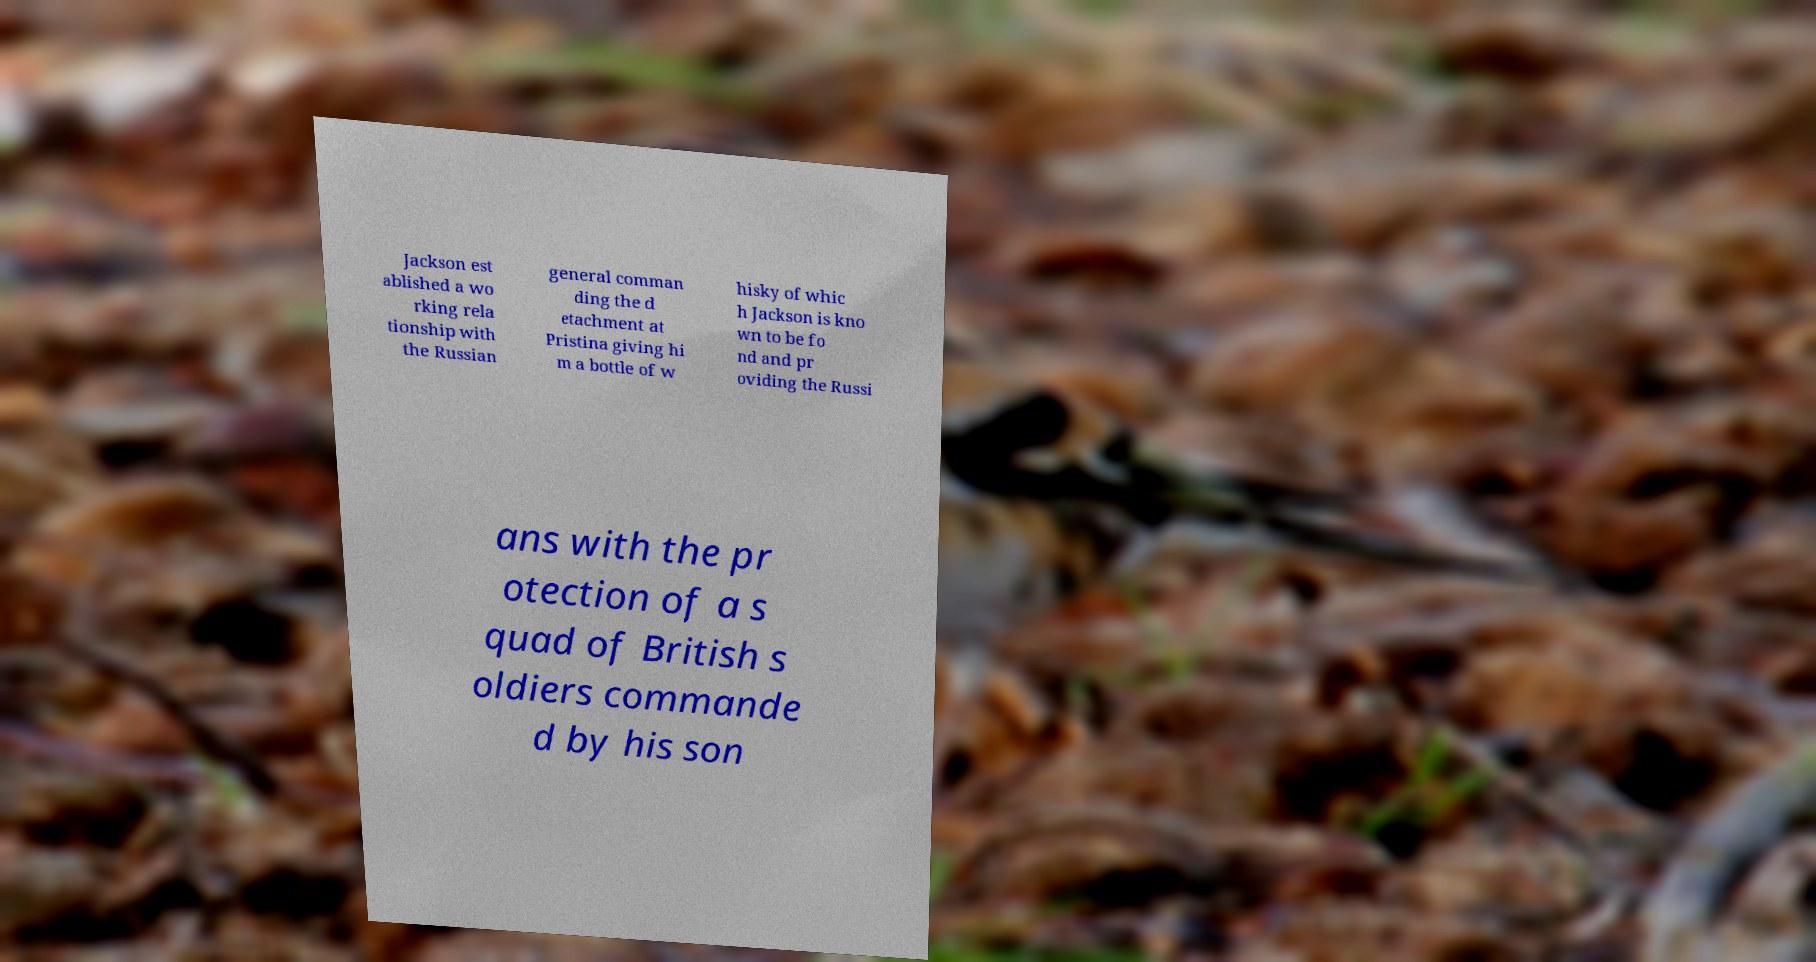There's text embedded in this image that I need extracted. Can you transcribe it verbatim? Jackson est ablished a wo rking rela tionship with the Russian general comman ding the d etachment at Pristina giving hi m a bottle of w hisky of whic h Jackson is kno wn to be fo nd and pr oviding the Russi ans with the pr otection of a s quad of British s oldiers commande d by his son 